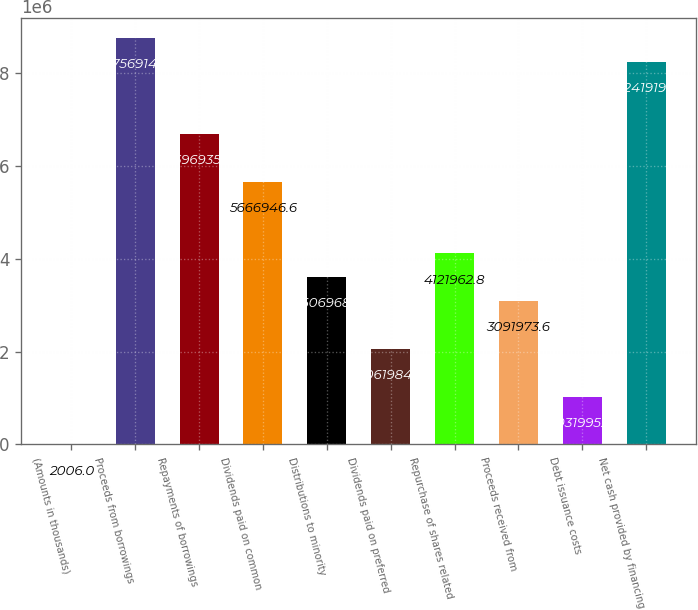Convert chart to OTSL. <chart><loc_0><loc_0><loc_500><loc_500><bar_chart><fcel>(Amounts in thousands)<fcel>Proceeds from borrowings<fcel>Repayments of borrowings<fcel>Dividends paid on common<fcel>Distributions to minority<fcel>Dividends paid on preferred<fcel>Repurchase of shares related<fcel>Proceeds received from<fcel>Debt issuance costs<fcel>Net cash provided by financing<nl><fcel>2006<fcel>8.75691e+06<fcel>6.69694e+06<fcel>5.66695e+06<fcel>3.60697e+06<fcel>2.06198e+06<fcel>4.12196e+06<fcel>3.09197e+06<fcel>1.032e+06<fcel>8.24192e+06<nl></chart> 